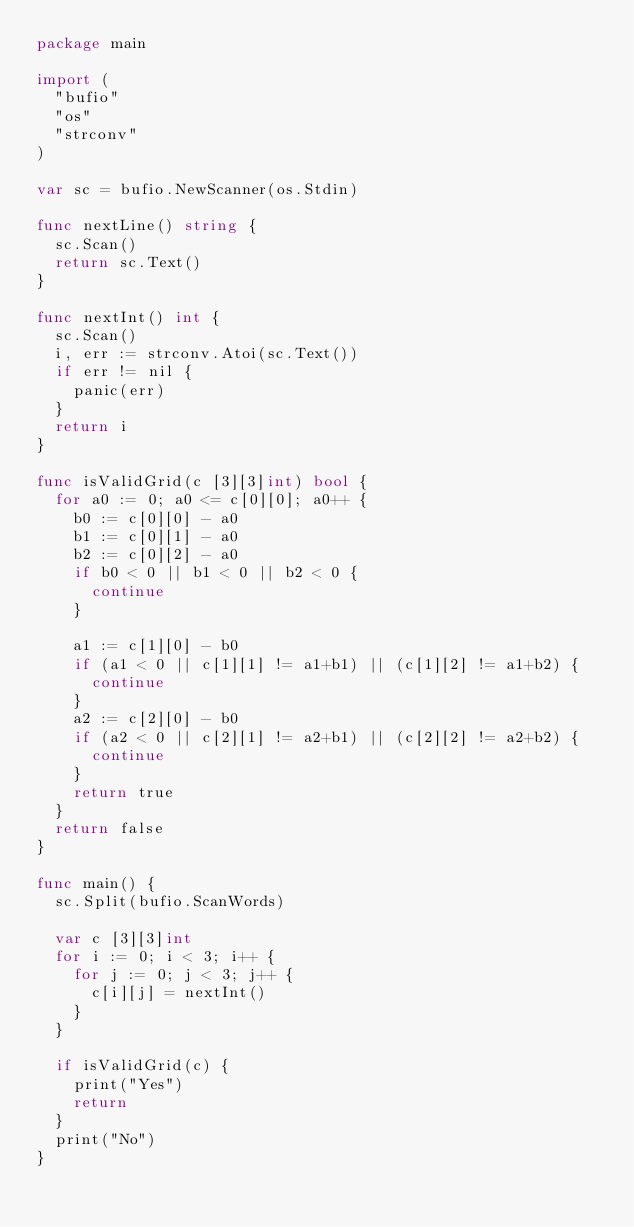<code> <loc_0><loc_0><loc_500><loc_500><_Go_>package main

import (
	"bufio"
	"os"
	"strconv"
)

var sc = bufio.NewScanner(os.Stdin)

func nextLine() string {
	sc.Scan()
	return sc.Text()
}

func nextInt() int {
	sc.Scan()
	i, err := strconv.Atoi(sc.Text())
	if err != nil {
		panic(err)
	}
	return i
}

func isValidGrid(c [3][3]int) bool {
	for a0 := 0; a0 <= c[0][0]; a0++ {
		b0 := c[0][0] - a0
		b1 := c[0][1] - a0
		b2 := c[0][2] - a0
		if b0 < 0 || b1 < 0 || b2 < 0 {
			continue
		}

		a1 := c[1][0] - b0
		if (a1 < 0 || c[1][1] != a1+b1) || (c[1][2] != a1+b2) {
			continue
		}
		a2 := c[2][0] - b0
		if (a2 < 0 || c[2][1] != a2+b1) || (c[2][2] != a2+b2) {
			continue
		}
		return true
	}
	return false
}

func main() {
	sc.Split(bufio.ScanWords)

	var c [3][3]int
	for i := 0; i < 3; i++ {
		for j := 0; j < 3; j++ {
			c[i][j] = nextInt()
		}
	}

	if isValidGrid(c) {
		print("Yes")
		return
	}
	print("No")
}
</code> 